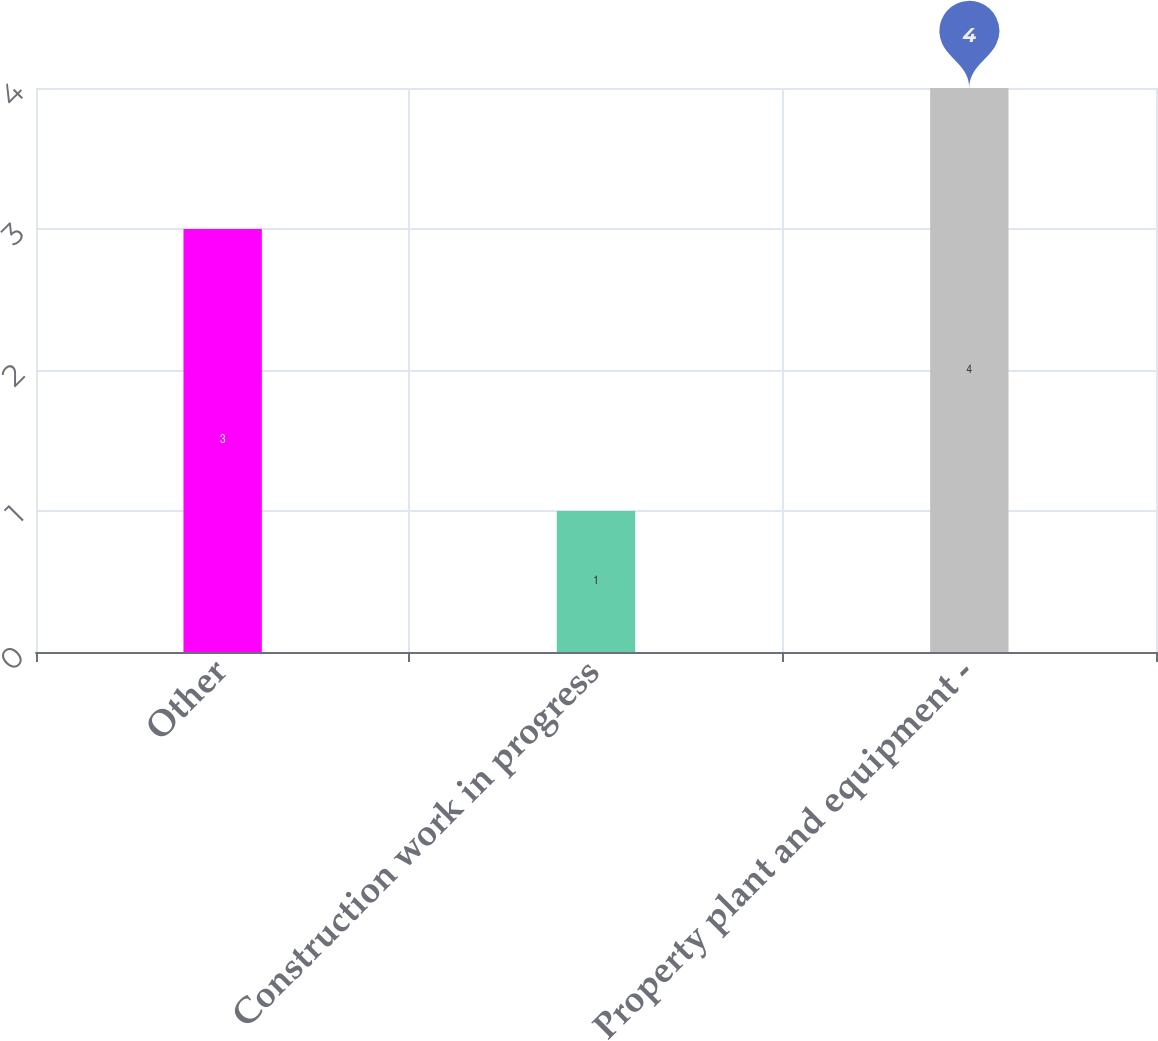Convert chart. <chart><loc_0><loc_0><loc_500><loc_500><bar_chart><fcel>Other<fcel>Construction work in progress<fcel>Property plant and equipment -<nl><fcel>3<fcel>1<fcel>4<nl></chart> 